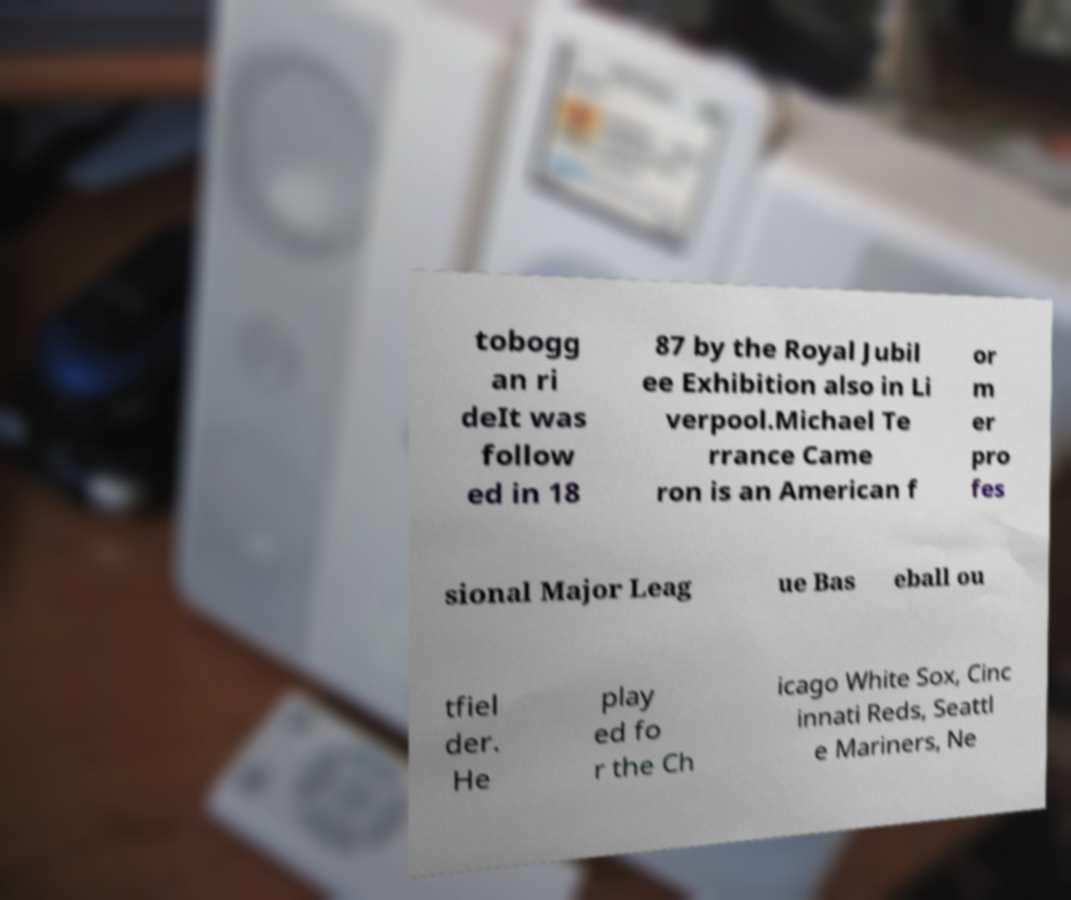What messages or text are displayed in this image? I need them in a readable, typed format. tobogg an ri deIt was follow ed in 18 87 by the Royal Jubil ee Exhibition also in Li verpool.Michael Te rrance Came ron is an American f or m er pro fes sional Major Leag ue Bas eball ou tfiel der. He play ed fo r the Ch icago White Sox, Cinc innati Reds, Seattl e Mariners, Ne 